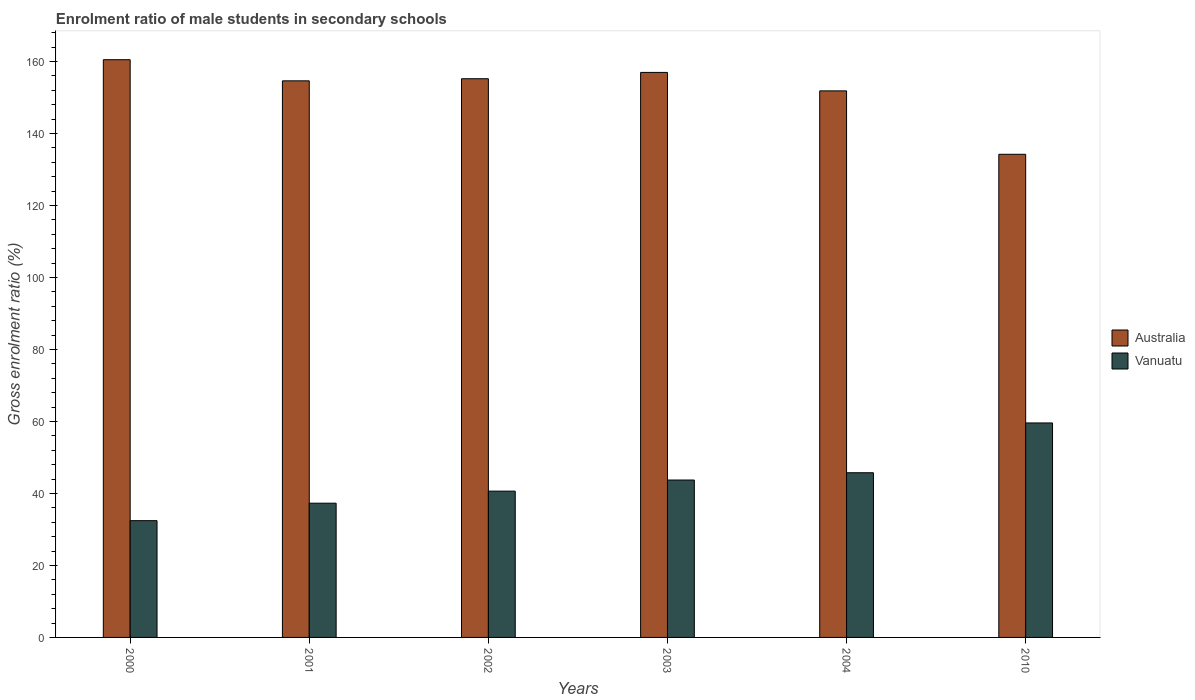How many different coloured bars are there?
Ensure brevity in your answer.  2. Are the number of bars on each tick of the X-axis equal?
Keep it short and to the point. Yes. How many bars are there on the 2nd tick from the left?
Your response must be concise. 2. What is the enrolment ratio of male students in secondary schools in Australia in 2010?
Provide a short and direct response. 134.24. Across all years, what is the maximum enrolment ratio of male students in secondary schools in Australia?
Make the answer very short. 160.52. Across all years, what is the minimum enrolment ratio of male students in secondary schools in Australia?
Make the answer very short. 134.24. In which year was the enrolment ratio of male students in secondary schools in Australia maximum?
Ensure brevity in your answer.  2000. What is the total enrolment ratio of male students in secondary schools in Vanuatu in the graph?
Your answer should be very brief. 259.48. What is the difference between the enrolment ratio of male students in secondary schools in Australia in 2002 and that in 2004?
Your response must be concise. 3.38. What is the difference between the enrolment ratio of male students in secondary schools in Vanuatu in 2010 and the enrolment ratio of male students in secondary schools in Australia in 2002?
Provide a succinct answer. -95.64. What is the average enrolment ratio of male students in secondary schools in Vanuatu per year?
Your answer should be compact. 43.25. In the year 2004, what is the difference between the enrolment ratio of male students in secondary schools in Australia and enrolment ratio of male students in secondary schools in Vanuatu?
Offer a terse response. 106.1. What is the ratio of the enrolment ratio of male students in secondary schools in Vanuatu in 2000 to that in 2010?
Your response must be concise. 0.54. Is the enrolment ratio of male students in secondary schools in Vanuatu in 2002 less than that in 2004?
Provide a succinct answer. Yes. Is the difference between the enrolment ratio of male students in secondary schools in Australia in 2000 and 2010 greater than the difference between the enrolment ratio of male students in secondary schools in Vanuatu in 2000 and 2010?
Keep it short and to the point. Yes. What is the difference between the highest and the second highest enrolment ratio of male students in secondary schools in Vanuatu?
Your response must be concise. 13.83. What is the difference between the highest and the lowest enrolment ratio of male students in secondary schools in Vanuatu?
Give a very brief answer. 27.15. Is the sum of the enrolment ratio of male students in secondary schools in Australia in 2002 and 2004 greater than the maximum enrolment ratio of male students in secondary schools in Vanuatu across all years?
Make the answer very short. Yes. What does the 1st bar from the left in 2010 represents?
Give a very brief answer. Australia. What does the 1st bar from the right in 2000 represents?
Offer a terse response. Vanuatu. How many bars are there?
Offer a terse response. 12. Are all the bars in the graph horizontal?
Provide a short and direct response. No. How many years are there in the graph?
Ensure brevity in your answer.  6. What is the difference between two consecutive major ticks on the Y-axis?
Give a very brief answer. 20. Does the graph contain any zero values?
Offer a very short reply. No. Does the graph contain grids?
Your answer should be compact. No. How are the legend labels stacked?
Offer a very short reply. Vertical. What is the title of the graph?
Provide a succinct answer. Enrolment ratio of male students in secondary schools. Does "OECD members" appear as one of the legend labels in the graph?
Keep it short and to the point. No. What is the Gross enrolment ratio (%) in Australia in 2000?
Provide a short and direct response. 160.52. What is the Gross enrolment ratio (%) of Vanuatu in 2000?
Provide a short and direct response. 32.44. What is the Gross enrolment ratio (%) in Australia in 2001?
Give a very brief answer. 154.65. What is the Gross enrolment ratio (%) of Vanuatu in 2001?
Offer a very short reply. 37.3. What is the Gross enrolment ratio (%) in Australia in 2002?
Give a very brief answer. 155.24. What is the Gross enrolment ratio (%) of Vanuatu in 2002?
Give a very brief answer. 40.65. What is the Gross enrolment ratio (%) in Australia in 2003?
Your answer should be compact. 156.99. What is the Gross enrolment ratio (%) in Vanuatu in 2003?
Keep it short and to the point. 43.74. What is the Gross enrolment ratio (%) in Australia in 2004?
Give a very brief answer. 151.86. What is the Gross enrolment ratio (%) in Vanuatu in 2004?
Your answer should be very brief. 45.76. What is the Gross enrolment ratio (%) in Australia in 2010?
Your response must be concise. 134.24. What is the Gross enrolment ratio (%) in Vanuatu in 2010?
Provide a short and direct response. 59.59. Across all years, what is the maximum Gross enrolment ratio (%) in Australia?
Your answer should be compact. 160.52. Across all years, what is the maximum Gross enrolment ratio (%) of Vanuatu?
Make the answer very short. 59.59. Across all years, what is the minimum Gross enrolment ratio (%) in Australia?
Provide a short and direct response. 134.24. Across all years, what is the minimum Gross enrolment ratio (%) of Vanuatu?
Your answer should be compact. 32.44. What is the total Gross enrolment ratio (%) of Australia in the graph?
Provide a short and direct response. 913.5. What is the total Gross enrolment ratio (%) of Vanuatu in the graph?
Provide a succinct answer. 259.48. What is the difference between the Gross enrolment ratio (%) in Australia in 2000 and that in 2001?
Provide a short and direct response. 5.87. What is the difference between the Gross enrolment ratio (%) in Vanuatu in 2000 and that in 2001?
Ensure brevity in your answer.  -4.85. What is the difference between the Gross enrolment ratio (%) of Australia in 2000 and that in 2002?
Offer a very short reply. 5.28. What is the difference between the Gross enrolment ratio (%) of Vanuatu in 2000 and that in 2002?
Ensure brevity in your answer.  -8.21. What is the difference between the Gross enrolment ratio (%) in Australia in 2000 and that in 2003?
Provide a short and direct response. 3.53. What is the difference between the Gross enrolment ratio (%) in Vanuatu in 2000 and that in 2003?
Offer a terse response. -11.29. What is the difference between the Gross enrolment ratio (%) in Australia in 2000 and that in 2004?
Offer a terse response. 8.66. What is the difference between the Gross enrolment ratio (%) of Vanuatu in 2000 and that in 2004?
Provide a succinct answer. -13.32. What is the difference between the Gross enrolment ratio (%) in Australia in 2000 and that in 2010?
Keep it short and to the point. 26.28. What is the difference between the Gross enrolment ratio (%) in Vanuatu in 2000 and that in 2010?
Keep it short and to the point. -27.15. What is the difference between the Gross enrolment ratio (%) of Australia in 2001 and that in 2002?
Ensure brevity in your answer.  -0.59. What is the difference between the Gross enrolment ratio (%) in Vanuatu in 2001 and that in 2002?
Offer a very short reply. -3.35. What is the difference between the Gross enrolment ratio (%) of Australia in 2001 and that in 2003?
Your response must be concise. -2.34. What is the difference between the Gross enrolment ratio (%) of Vanuatu in 2001 and that in 2003?
Your response must be concise. -6.44. What is the difference between the Gross enrolment ratio (%) of Australia in 2001 and that in 2004?
Offer a terse response. 2.79. What is the difference between the Gross enrolment ratio (%) in Vanuatu in 2001 and that in 2004?
Offer a very short reply. -8.46. What is the difference between the Gross enrolment ratio (%) in Australia in 2001 and that in 2010?
Your answer should be very brief. 20.41. What is the difference between the Gross enrolment ratio (%) of Vanuatu in 2001 and that in 2010?
Your answer should be very brief. -22.3. What is the difference between the Gross enrolment ratio (%) of Australia in 2002 and that in 2003?
Offer a very short reply. -1.75. What is the difference between the Gross enrolment ratio (%) in Vanuatu in 2002 and that in 2003?
Provide a short and direct response. -3.09. What is the difference between the Gross enrolment ratio (%) in Australia in 2002 and that in 2004?
Keep it short and to the point. 3.38. What is the difference between the Gross enrolment ratio (%) in Vanuatu in 2002 and that in 2004?
Keep it short and to the point. -5.11. What is the difference between the Gross enrolment ratio (%) in Australia in 2002 and that in 2010?
Provide a succinct answer. 21. What is the difference between the Gross enrolment ratio (%) of Vanuatu in 2002 and that in 2010?
Ensure brevity in your answer.  -18.94. What is the difference between the Gross enrolment ratio (%) in Australia in 2003 and that in 2004?
Make the answer very short. 5.13. What is the difference between the Gross enrolment ratio (%) of Vanuatu in 2003 and that in 2004?
Your answer should be very brief. -2.02. What is the difference between the Gross enrolment ratio (%) in Australia in 2003 and that in 2010?
Provide a succinct answer. 22.75. What is the difference between the Gross enrolment ratio (%) of Vanuatu in 2003 and that in 2010?
Your response must be concise. -15.86. What is the difference between the Gross enrolment ratio (%) in Australia in 2004 and that in 2010?
Keep it short and to the point. 17.62. What is the difference between the Gross enrolment ratio (%) of Vanuatu in 2004 and that in 2010?
Give a very brief answer. -13.83. What is the difference between the Gross enrolment ratio (%) in Australia in 2000 and the Gross enrolment ratio (%) in Vanuatu in 2001?
Offer a terse response. 123.22. What is the difference between the Gross enrolment ratio (%) in Australia in 2000 and the Gross enrolment ratio (%) in Vanuatu in 2002?
Offer a very short reply. 119.87. What is the difference between the Gross enrolment ratio (%) in Australia in 2000 and the Gross enrolment ratio (%) in Vanuatu in 2003?
Offer a very short reply. 116.78. What is the difference between the Gross enrolment ratio (%) in Australia in 2000 and the Gross enrolment ratio (%) in Vanuatu in 2004?
Provide a short and direct response. 114.76. What is the difference between the Gross enrolment ratio (%) in Australia in 2000 and the Gross enrolment ratio (%) in Vanuatu in 2010?
Offer a very short reply. 100.93. What is the difference between the Gross enrolment ratio (%) of Australia in 2001 and the Gross enrolment ratio (%) of Vanuatu in 2002?
Offer a terse response. 114. What is the difference between the Gross enrolment ratio (%) in Australia in 2001 and the Gross enrolment ratio (%) in Vanuatu in 2003?
Give a very brief answer. 110.91. What is the difference between the Gross enrolment ratio (%) in Australia in 2001 and the Gross enrolment ratio (%) in Vanuatu in 2004?
Make the answer very short. 108.89. What is the difference between the Gross enrolment ratio (%) of Australia in 2001 and the Gross enrolment ratio (%) of Vanuatu in 2010?
Keep it short and to the point. 95.05. What is the difference between the Gross enrolment ratio (%) in Australia in 2002 and the Gross enrolment ratio (%) in Vanuatu in 2003?
Your answer should be compact. 111.5. What is the difference between the Gross enrolment ratio (%) in Australia in 2002 and the Gross enrolment ratio (%) in Vanuatu in 2004?
Make the answer very short. 109.48. What is the difference between the Gross enrolment ratio (%) of Australia in 2002 and the Gross enrolment ratio (%) of Vanuatu in 2010?
Ensure brevity in your answer.  95.64. What is the difference between the Gross enrolment ratio (%) in Australia in 2003 and the Gross enrolment ratio (%) in Vanuatu in 2004?
Ensure brevity in your answer.  111.23. What is the difference between the Gross enrolment ratio (%) in Australia in 2003 and the Gross enrolment ratio (%) in Vanuatu in 2010?
Your answer should be compact. 97.4. What is the difference between the Gross enrolment ratio (%) in Australia in 2004 and the Gross enrolment ratio (%) in Vanuatu in 2010?
Offer a very short reply. 92.27. What is the average Gross enrolment ratio (%) in Australia per year?
Provide a succinct answer. 152.25. What is the average Gross enrolment ratio (%) of Vanuatu per year?
Give a very brief answer. 43.25. In the year 2000, what is the difference between the Gross enrolment ratio (%) in Australia and Gross enrolment ratio (%) in Vanuatu?
Make the answer very short. 128.08. In the year 2001, what is the difference between the Gross enrolment ratio (%) in Australia and Gross enrolment ratio (%) in Vanuatu?
Provide a succinct answer. 117.35. In the year 2002, what is the difference between the Gross enrolment ratio (%) of Australia and Gross enrolment ratio (%) of Vanuatu?
Your response must be concise. 114.59. In the year 2003, what is the difference between the Gross enrolment ratio (%) in Australia and Gross enrolment ratio (%) in Vanuatu?
Give a very brief answer. 113.26. In the year 2004, what is the difference between the Gross enrolment ratio (%) of Australia and Gross enrolment ratio (%) of Vanuatu?
Make the answer very short. 106.1. In the year 2010, what is the difference between the Gross enrolment ratio (%) of Australia and Gross enrolment ratio (%) of Vanuatu?
Provide a short and direct response. 74.65. What is the ratio of the Gross enrolment ratio (%) of Australia in 2000 to that in 2001?
Your answer should be compact. 1.04. What is the ratio of the Gross enrolment ratio (%) of Vanuatu in 2000 to that in 2001?
Provide a succinct answer. 0.87. What is the ratio of the Gross enrolment ratio (%) in Australia in 2000 to that in 2002?
Your answer should be compact. 1.03. What is the ratio of the Gross enrolment ratio (%) of Vanuatu in 2000 to that in 2002?
Your answer should be very brief. 0.8. What is the ratio of the Gross enrolment ratio (%) in Australia in 2000 to that in 2003?
Keep it short and to the point. 1.02. What is the ratio of the Gross enrolment ratio (%) of Vanuatu in 2000 to that in 2003?
Give a very brief answer. 0.74. What is the ratio of the Gross enrolment ratio (%) of Australia in 2000 to that in 2004?
Your answer should be very brief. 1.06. What is the ratio of the Gross enrolment ratio (%) in Vanuatu in 2000 to that in 2004?
Offer a terse response. 0.71. What is the ratio of the Gross enrolment ratio (%) of Australia in 2000 to that in 2010?
Offer a terse response. 1.2. What is the ratio of the Gross enrolment ratio (%) in Vanuatu in 2000 to that in 2010?
Ensure brevity in your answer.  0.54. What is the ratio of the Gross enrolment ratio (%) in Australia in 2001 to that in 2002?
Your answer should be very brief. 1. What is the ratio of the Gross enrolment ratio (%) of Vanuatu in 2001 to that in 2002?
Your response must be concise. 0.92. What is the ratio of the Gross enrolment ratio (%) of Australia in 2001 to that in 2003?
Keep it short and to the point. 0.99. What is the ratio of the Gross enrolment ratio (%) in Vanuatu in 2001 to that in 2003?
Provide a short and direct response. 0.85. What is the ratio of the Gross enrolment ratio (%) in Australia in 2001 to that in 2004?
Keep it short and to the point. 1.02. What is the ratio of the Gross enrolment ratio (%) in Vanuatu in 2001 to that in 2004?
Your answer should be compact. 0.81. What is the ratio of the Gross enrolment ratio (%) in Australia in 2001 to that in 2010?
Offer a very short reply. 1.15. What is the ratio of the Gross enrolment ratio (%) of Vanuatu in 2001 to that in 2010?
Ensure brevity in your answer.  0.63. What is the ratio of the Gross enrolment ratio (%) of Vanuatu in 2002 to that in 2003?
Your response must be concise. 0.93. What is the ratio of the Gross enrolment ratio (%) of Australia in 2002 to that in 2004?
Your answer should be very brief. 1.02. What is the ratio of the Gross enrolment ratio (%) of Vanuatu in 2002 to that in 2004?
Offer a terse response. 0.89. What is the ratio of the Gross enrolment ratio (%) in Australia in 2002 to that in 2010?
Provide a succinct answer. 1.16. What is the ratio of the Gross enrolment ratio (%) in Vanuatu in 2002 to that in 2010?
Provide a short and direct response. 0.68. What is the ratio of the Gross enrolment ratio (%) in Australia in 2003 to that in 2004?
Give a very brief answer. 1.03. What is the ratio of the Gross enrolment ratio (%) in Vanuatu in 2003 to that in 2004?
Offer a very short reply. 0.96. What is the ratio of the Gross enrolment ratio (%) in Australia in 2003 to that in 2010?
Provide a succinct answer. 1.17. What is the ratio of the Gross enrolment ratio (%) in Vanuatu in 2003 to that in 2010?
Your answer should be compact. 0.73. What is the ratio of the Gross enrolment ratio (%) of Australia in 2004 to that in 2010?
Offer a very short reply. 1.13. What is the ratio of the Gross enrolment ratio (%) of Vanuatu in 2004 to that in 2010?
Your response must be concise. 0.77. What is the difference between the highest and the second highest Gross enrolment ratio (%) of Australia?
Your answer should be very brief. 3.53. What is the difference between the highest and the second highest Gross enrolment ratio (%) of Vanuatu?
Your answer should be very brief. 13.83. What is the difference between the highest and the lowest Gross enrolment ratio (%) in Australia?
Give a very brief answer. 26.28. What is the difference between the highest and the lowest Gross enrolment ratio (%) of Vanuatu?
Your response must be concise. 27.15. 